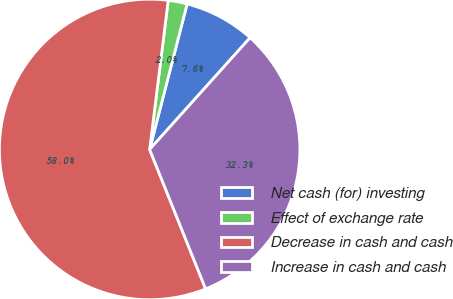Convert chart. <chart><loc_0><loc_0><loc_500><loc_500><pie_chart><fcel>Net cash (for) investing<fcel>Effect of exchange rate<fcel>Decrease in cash and cash<fcel>Increase in cash and cash<nl><fcel>7.64%<fcel>2.04%<fcel>58.05%<fcel>32.27%<nl></chart> 